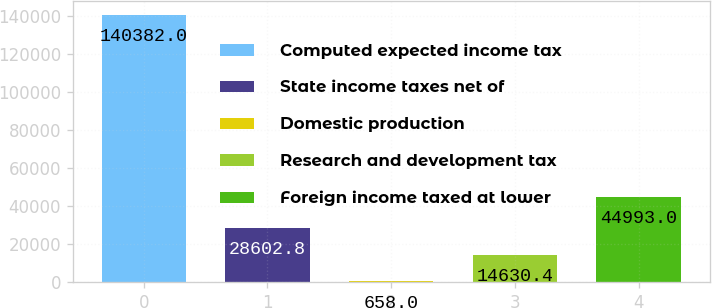<chart> <loc_0><loc_0><loc_500><loc_500><bar_chart><fcel>Computed expected income tax<fcel>State income taxes net of<fcel>Domestic production<fcel>Research and development tax<fcel>Foreign income taxed at lower<nl><fcel>140382<fcel>28602.8<fcel>658<fcel>14630.4<fcel>44993<nl></chart> 